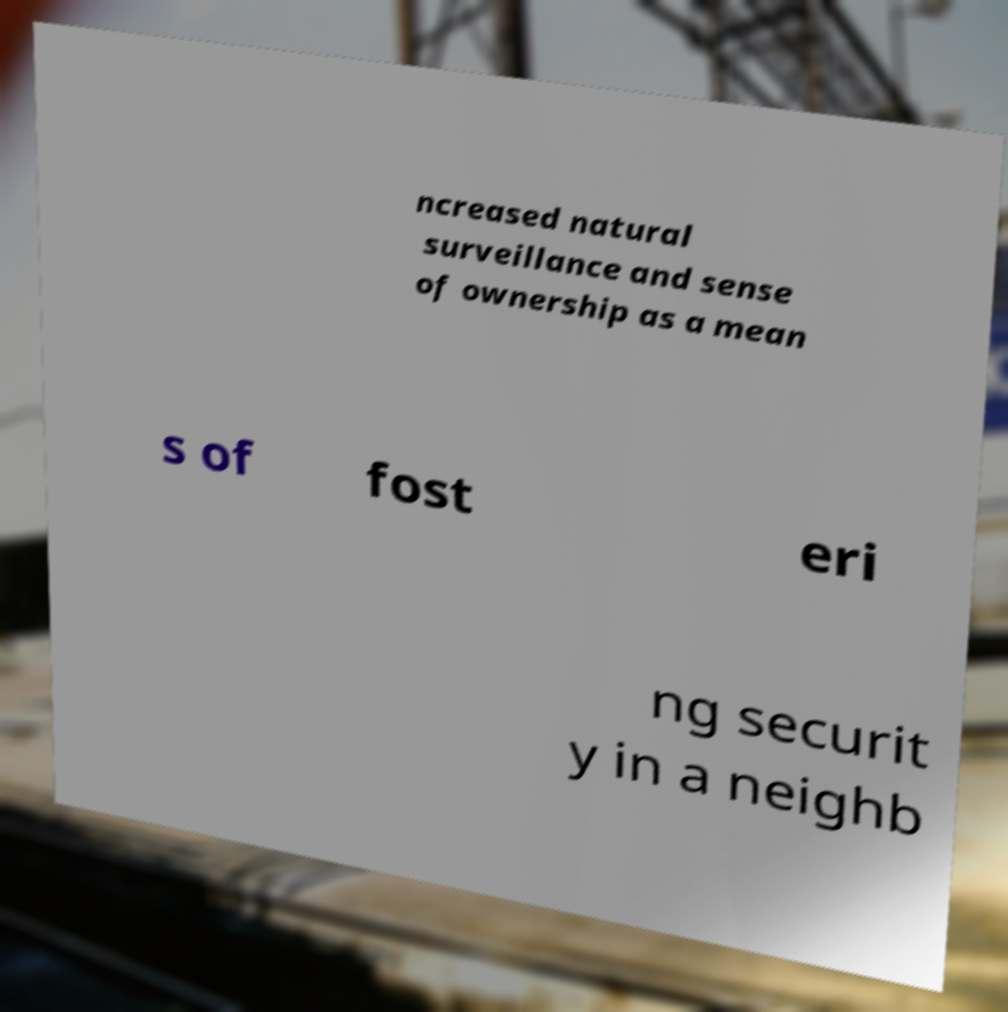Please read and relay the text visible in this image. What does it say? ncreased natural surveillance and sense of ownership as a mean s of fost eri ng securit y in a neighb 